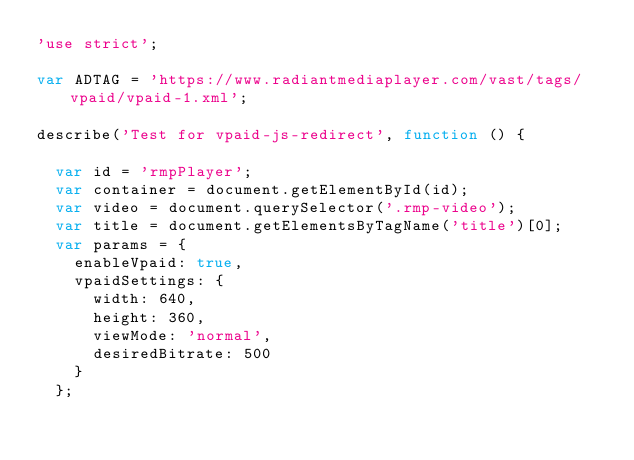Convert code to text. <code><loc_0><loc_0><loc_500><loc_500><_JavaScript_>'use strict';

var ADTAG = 'https://www.radiantmediaplayer.com/vast/tags/vpaid/vpaid-1.xml';

describe('Test for vpaid-js-redirect', function () {

  var id = 'rmpPlayer';
  var container = document.getElementById(id);
  var video = document.querySelector('.rmp-video');
  var title = document.getElementsByTagName('title')[0];
  var params = {
    enableVpaid: true,
    vpaidSettings: {
      width: 640,
      height: 360,
      viewMode: 'normal',
      desiredBitrate: 500
    }
  };</code> 